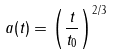<formula> <loc_0><loc_0><loc_500><loc_500>a ( t ) = \left ( \frac { t } { t _ { 0 } } \right ) ^ { 2 / 3 }</formula> 